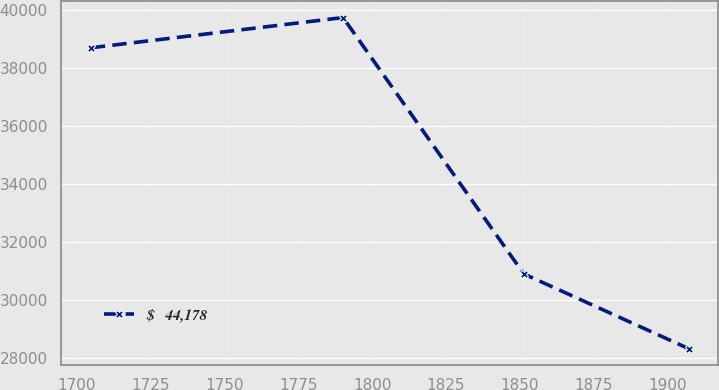Convert chart. <chart><loc_0><loc_0><loc_500><loc_500><line_chart><ecel><fcel>$   44,178<nl><fcel>1704.8<fcel>38694.2<nl><fcel>1790.16<fcel>39736.2<nl><fcel>1851.31<fcel>30905.5<nl><fcel>1907.04<fcel>28333.7<nl></chart> 